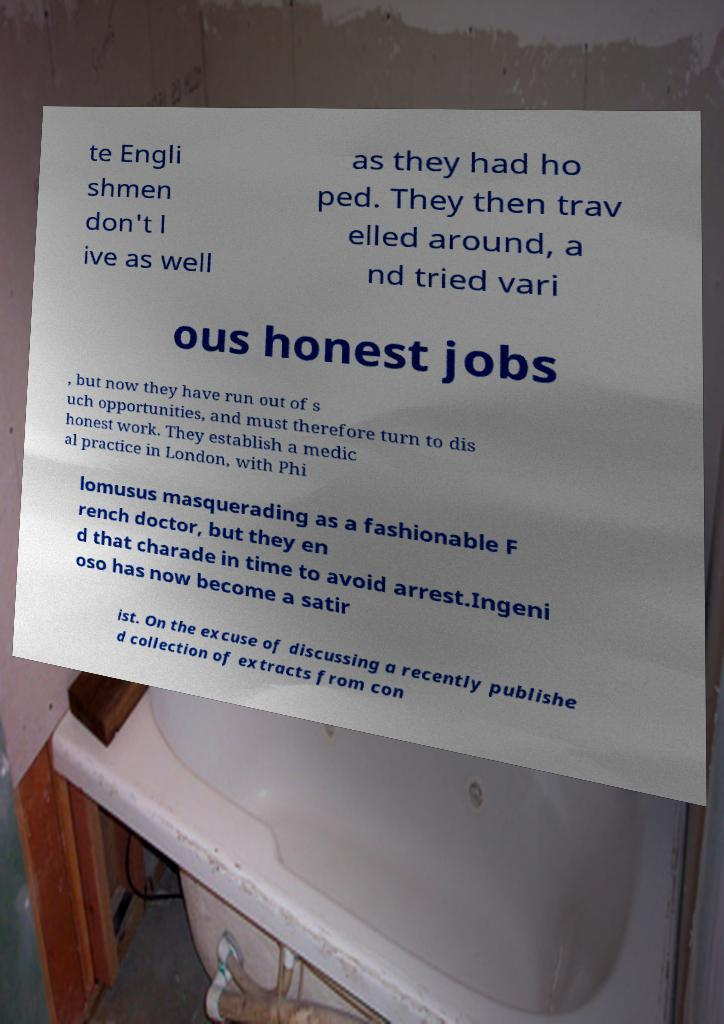Please read and relay the text visible in this image. What does it say? te Engli shmen don't l ive as well as they had ho ped. They then trav elled around, a nd tried vari ous honest jobs , but now they have run out of s uch opportunities, and must therefore turn to dis honest work. They establish a medic al practice in London, with Phi lomusus masquerading as a fashionable F rench doctor, but they en d that charade in time to avoid arrest.Ingeni oso has now become a satir ist. On the excuse of discussing a recently publishe d collection of extracts from con 